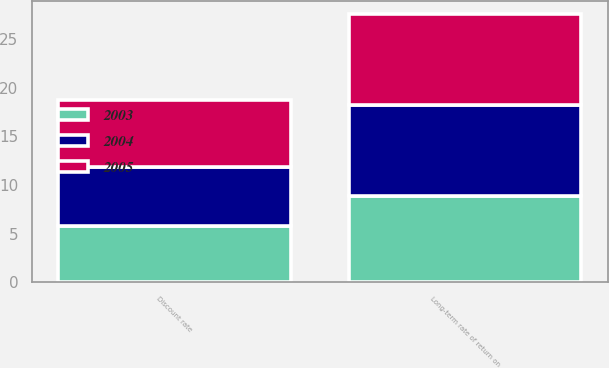<chart> <loc_0><loc_0><loc_500><loc_500><stacked_bar_chart><ecel><fcel>Discount rate<fcel>Long-term rate of return on<nl><fcel>2003<fcel>5.8<fcel>8.9<nl><fcel>2004<fcel>6<fcel>9.3<nl><fcel>2005<fcel>6.9<fcel>9.3<nl></chart> 